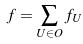<formula> <loc_0><loc_0><loc_500><loc_500>f = \sum _ { U \in O } f _ { U }</formula> 